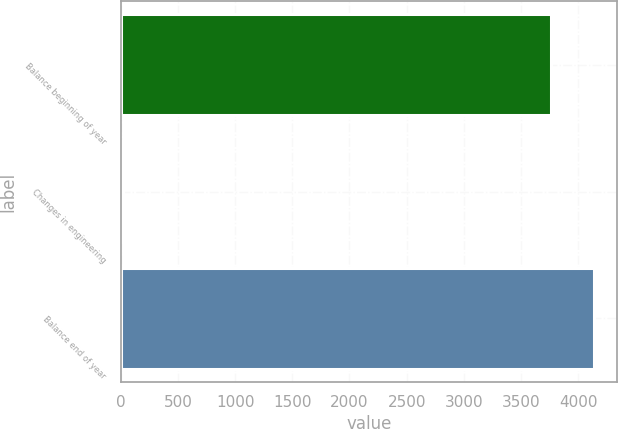<chart> <loc_0><loc_0><loc_500><loc_500><bar_chart><fcel>Balance beginning of year<fcel>Changes in engineering<fcel>Balance end of year<nl><fcel>3760<fcel>18<fcel>4136.9<nl></chart> 